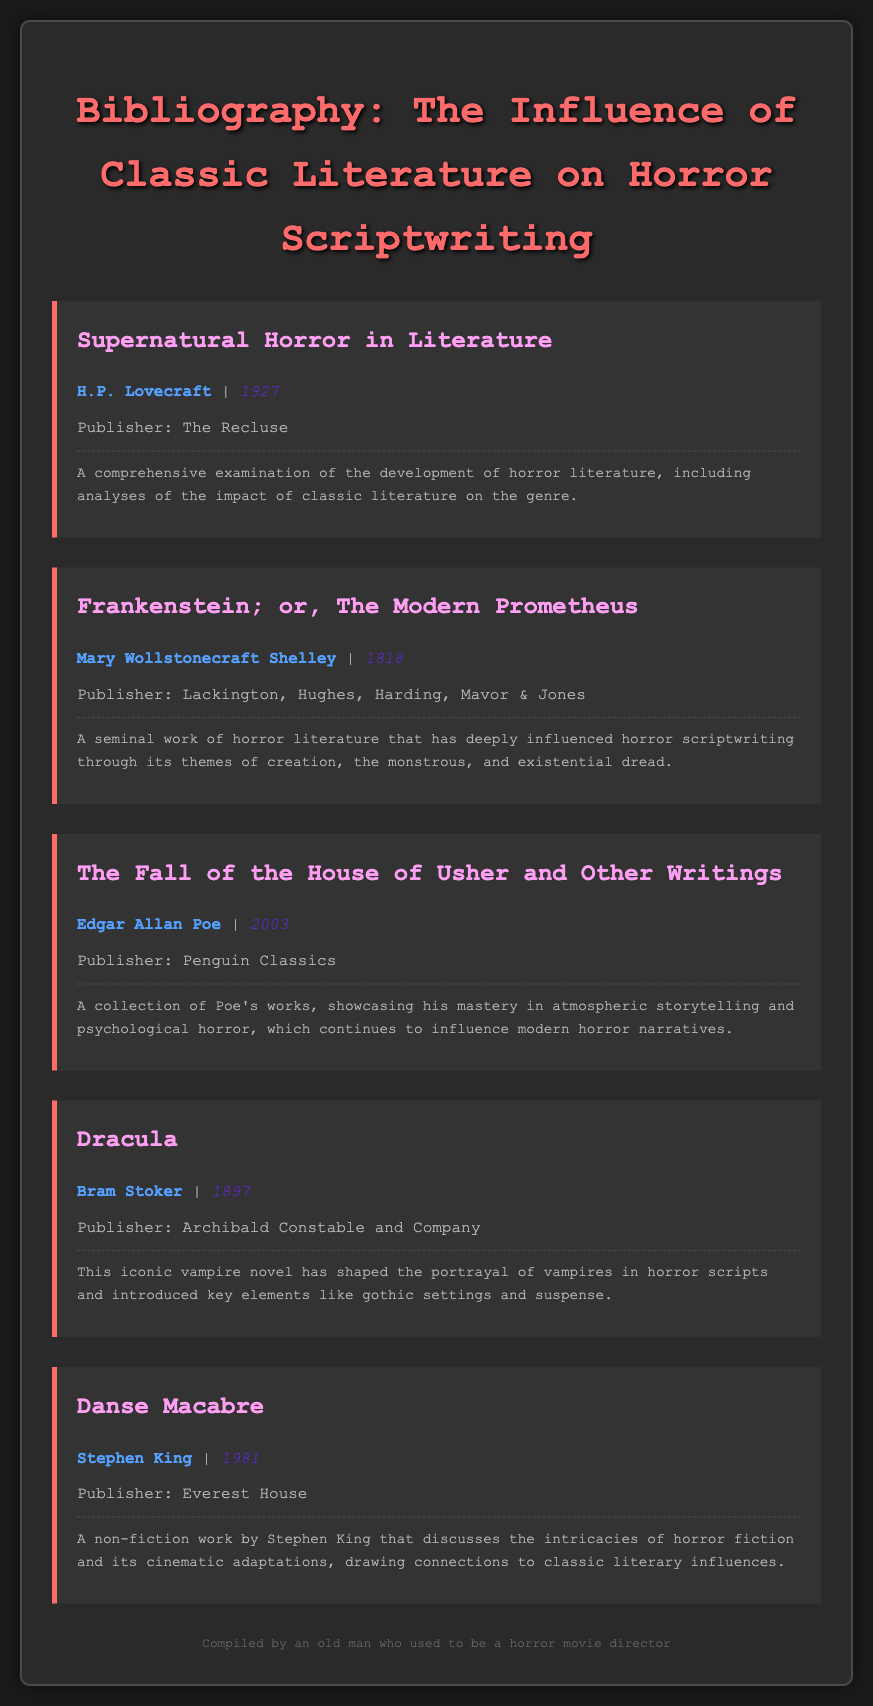What is the title of the first entry? The first entry is titled "Supernatural Horror in Literature."
Answer: Supernatural Horror in Literature Who is the author of "Frankenstein"? The author's name for "Frankenstein; or, The Modern Prometheus" is Mary Wollstonecraft Shelley.
Answer: Mary Wollstonecraft Shelley What year was "Dracula" published? "Dracula" was published in 1897.
Answer: 1897 Which author wrote "Danse Macabre"? The author of "Danse Macabre" is Stephen King.
Answer: Stephen King What is the main theme discussed in Shelley's "Frankenstein"? The themes include creation, the monstrous, and existential dread.
Answer: creation, the monstrous, and existential dread Which publisher released "The Fall of the House of Usher and Other Writings"? The publisher for this collection is Penguin Classics.
Answer: Penguin Classics How many entries are included in the bibliography? There are five entries in the bibliography.
Answer: five What genre does this bibliography focus on? This bibliography focuses on horror scriptwriting.
Answer: horror scriptwriting What type of work is "Danse Macabre"? "Danse Macabre" is a non-fiction work.
Answer: non-fiction 